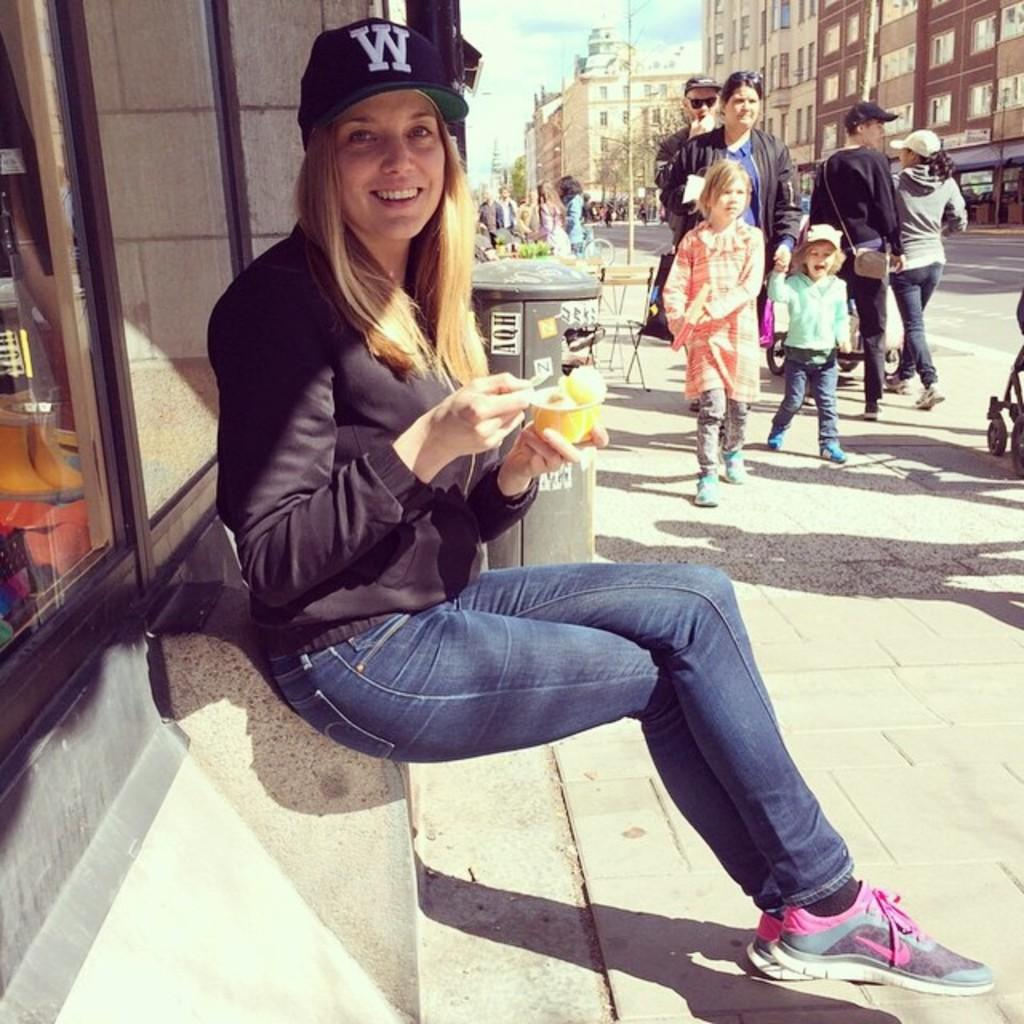What is the woman in the image wearing? The woman is wearing a black dress. What is the woman holding in her hand? The woman is holding an edible item in her hand. Can you describe the people in the right corner of the image? There are people standing in the right corner of the image. What can be seen in the background of the image? There are buildings and trees in the background of the image. What type of education can be seen in the image? There is no indication of education in the image; it features a woman, an edible item, people in the right corner, and a background with buildings and trees. 